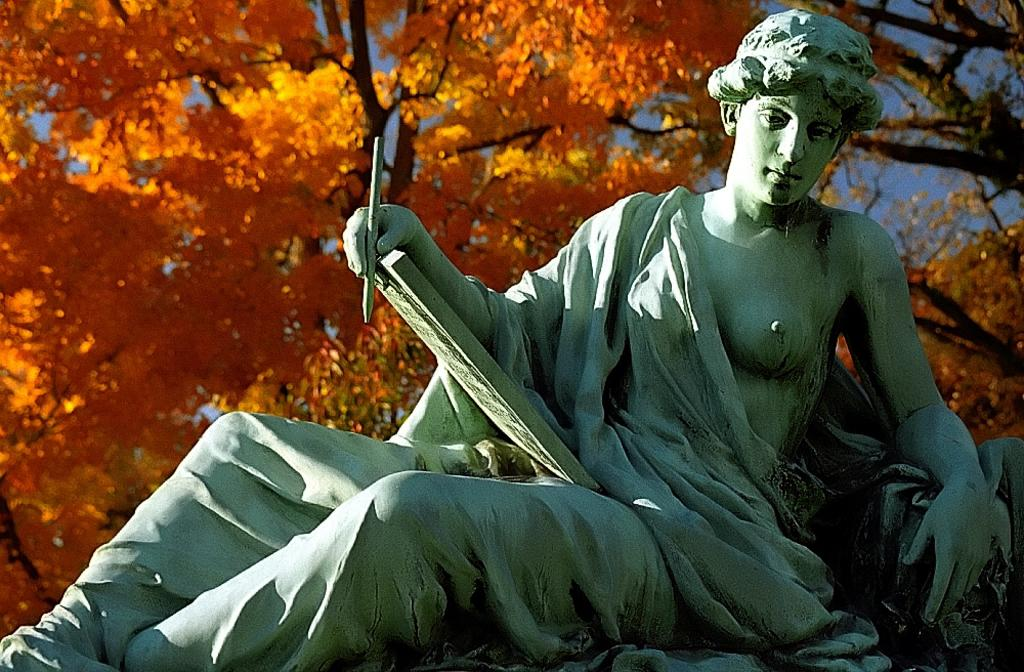What is the main subject of the image? There is a sculpture in the image. What type of natural elements can be seen in the image? There are trees and colorful flowers in the image. What is visible in the background of the image? The sky is visible in the image. How many hands are visible on the sculpture in the image? There are no hands visible on the sculpture in the image, as it is a sculpture and not a human figure. 